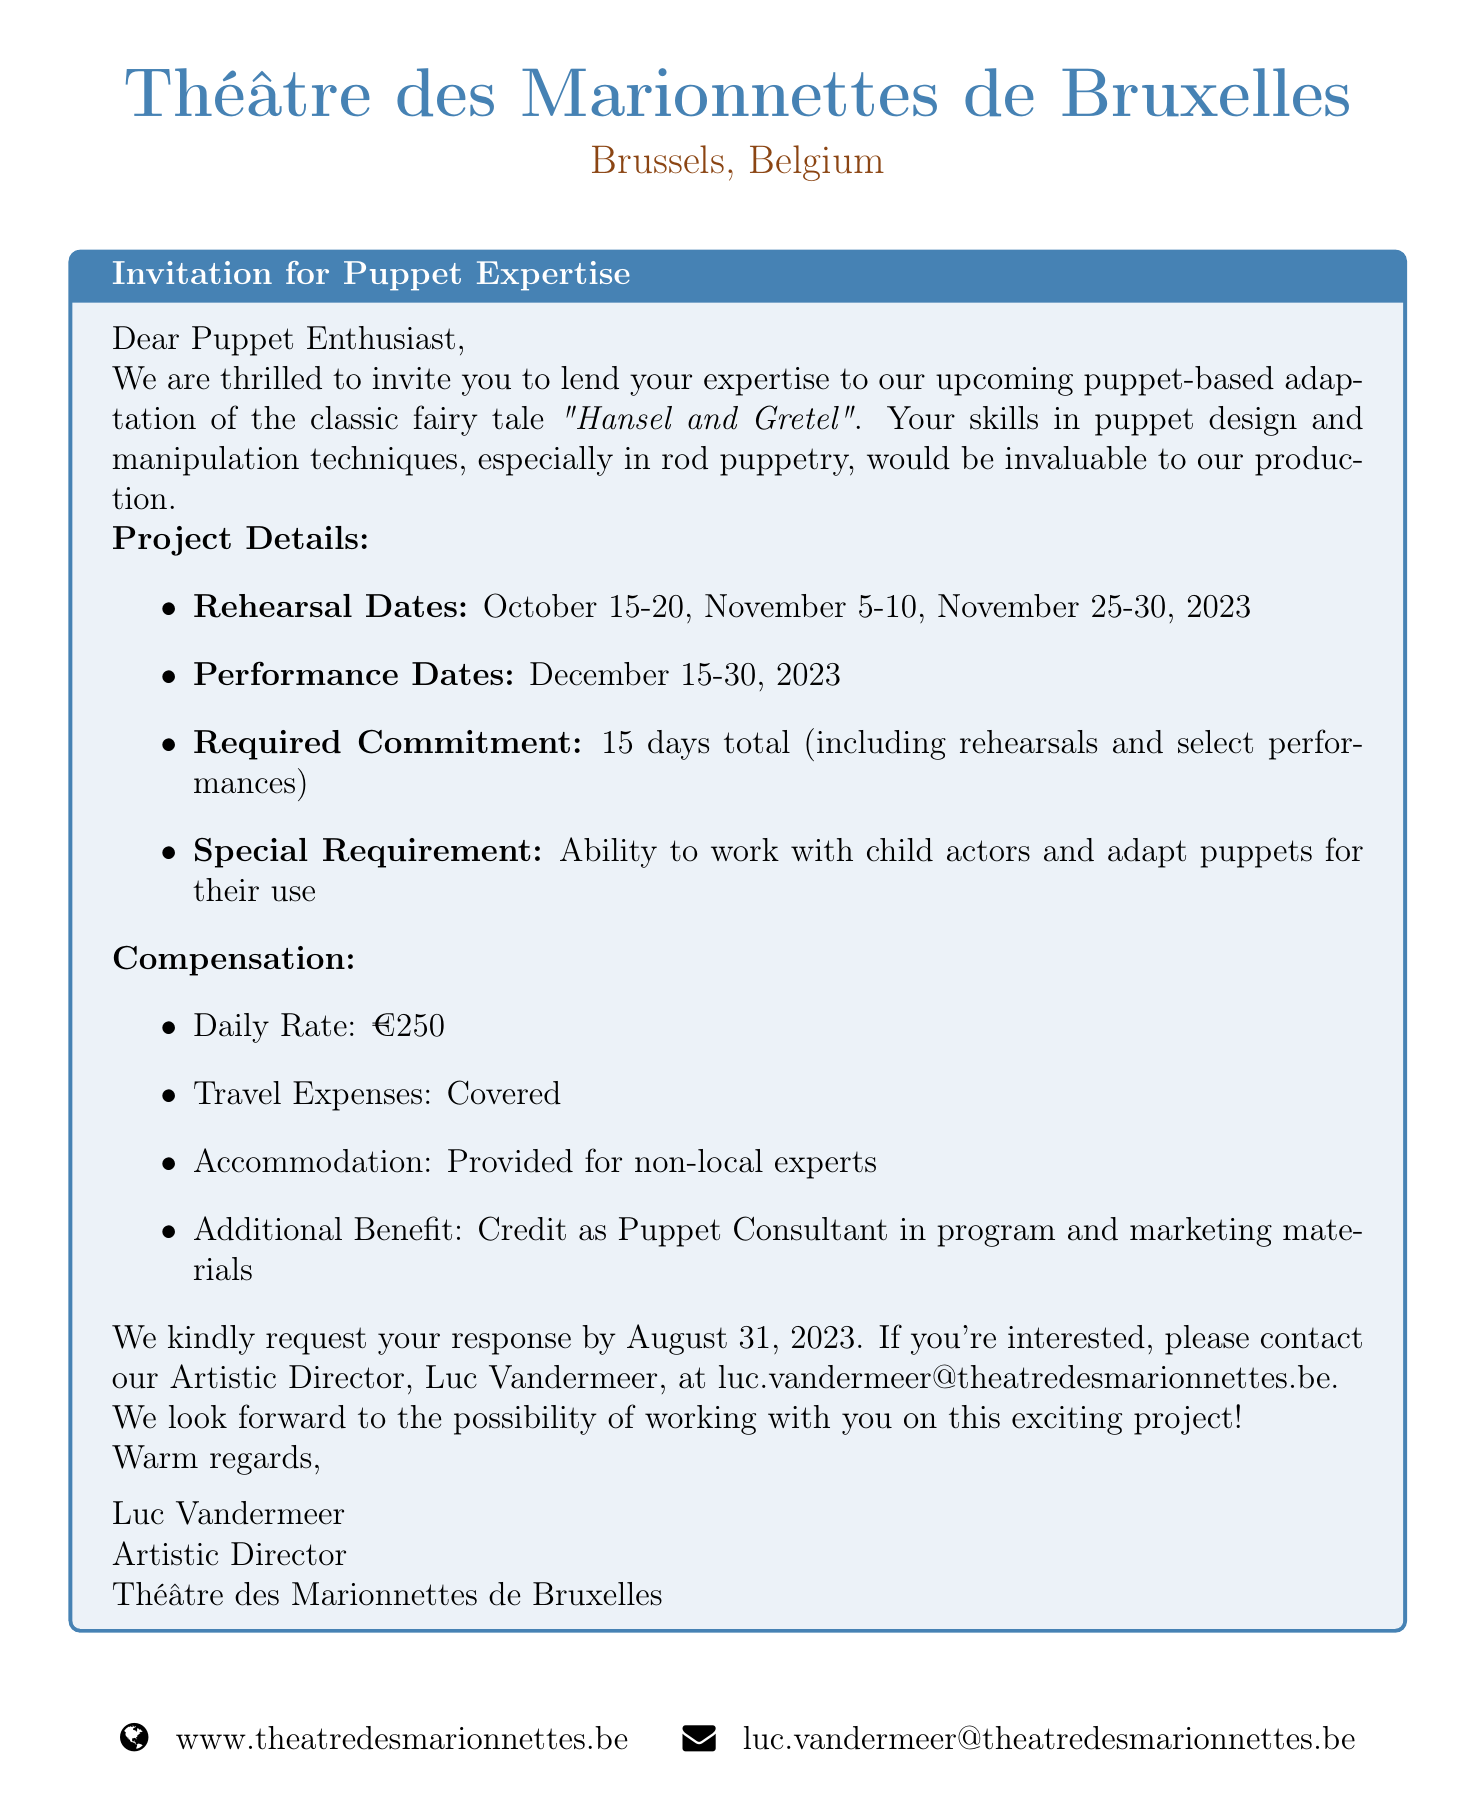What is the name of the theater? The name of the theater is mentioned in the document as part of the introduction.
Answer: Théâtre des Marionnettes de Bruxelles Who is the contact person for this project? The contact person is listed with their title in the document.
Answer: Luc Vandermeer What is the daily rate for the puppet consultant? The daily rate is specified clearly under the compensation section of the document.
Answer: €250 What are the performance dates? The performance dates are provided under the project details section.
Answer: December 15-30, 2023 What is the total number of days required for commitment? The required commitment is stated in the document under project details.
Answer: 15 days total When is the application deadline? The application deadline is given towards the end of the document.
Answer: August 31, 2023 What is the special requirement for the expert? The special requirement is outlined in the document related to expertise.
Answer: Ability to work with child actors and adapt puppets for their use What style of puppetry is being used in the adaptation? The puppetry style is specified in the request for expertise section.
Answer: Rod puppetry What contact email is provided for responses? The document includes an email address for contacting the theater.
Answer: luc.vandermeer@theatredesmarionnettes.be 